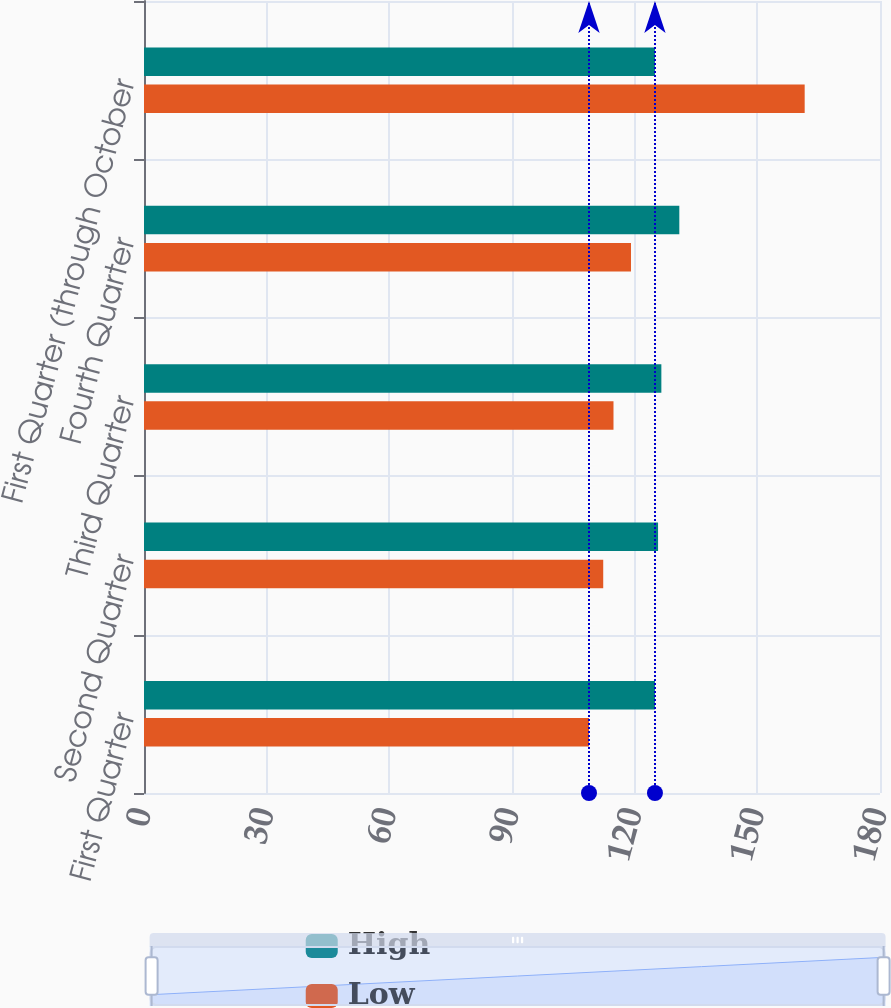Convert chart to OTSL. <chart><loc_0><loc_0><loc_500><loc_500><stacked_bar_chart><ecel><fcel>First Quarter<fcel>Second Quarter<fcel>Third Quarter<fcel>Fourth Quarter<fcel>First Quarter (through October<nl><fcel>High<fcel>124.96<fcel>125.72<fcel>126.53<fcel>130.92<fcel>124.96<nl><fcel>Low<fcel>108.83<fcel>112.31<fcel>114.82<fcel>119.1<fcel>161.58<nl></chart> 